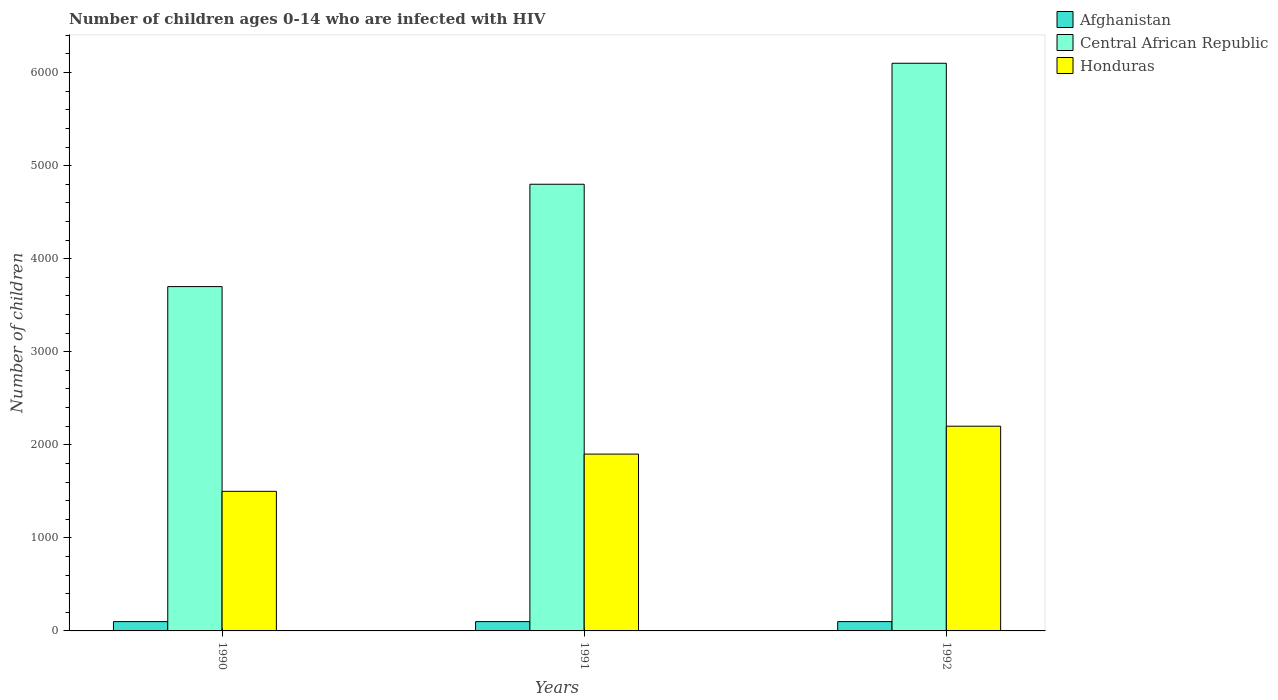How many groups of bars are there?
Offer a very short reply. 3. Are the number of bars per tick equal to the number of legend labels?
Provide a succinct answer. Yes. How many bars are there on the 3rd tick from the right?
Provide a short and direct response. 3. What is the label of the 1st group of bars from the left?
Your response must be concise. 1990. In how many cases, is the number of bars for a given year not equal to the number of legend labels?
Offer a very short reply. 0. What is the number of HIV infected children in Afghanistan in 1990?
Your response must be concise. 100. Across all years, what is the maximum number of HIV infected children in Central African Republic?
Provide a short and direct response. 6100. Across all years, what is the minimum number of HIV infected children in Honduras?
Offer a terse response. 1500. What is the total number of HIV infected children in Central African Republic in the graph?
Give a very brief answer. 1.46e+04. What is the difference between the number of HIV infected children in Afghanistan in 1992 and the number of HIV infected children in Honduras in 1990?
Give a very brief answer. -1400. What is the average number of HIV infected children in Central African Republic per year?
Provide a short and direct response. 4866.67. In the year 1990, what is the difference between the number of HIV infected children in Honduras and number of HIV infected children in Central African Republic?
Ensure brevity in your answer.  -2200. What is the ratio of the number of HIV infected children in Honduras in 1991 to that in 1992?
Your answer should be very brief. 0.86. Is the number of HIV infected children in Honduras in 1990 less than that in 1992?
Provide a succinct answer. Yes. What is the difference between the highest and the second highest number of HIV infected children in Honduras?
Make the answer very short. 300. What is the difference between the highest and the lowest number of HIV infected children in Central African Republic?
Give a very brief answer. 2400. In how many years, is the number of HIV infected children in Honduras greater than the average number of HIV infected children in Honduras taken over all years?
Provide a succinct answer. 2. Is the sum of the number of HIV infected children in Central African Republic in 1990 and 1992 greater than the maximum number of HIV infected children in Afghanistan across all years?
Keep it short and to the point. Yes. What does the 2nd bar from the left in 1992 represents?
Your answer should be compact. Central African Republic. What does the 2nd bar from the right in 1991 represents?
Ensure brevity in your answer.  Central African Republic. Is it the case that in every year, the sum of the number of HIV infected children in Central African Republic and number of HIV infected children in Afghanistan is greater than the number of HIV infected children in Honduras?
Offer a very short reply. Yes. How many bars are there?
Ensure brevity in your answer.  9. What is the difference between two consecutive major ticks on the Y-axis?
Provide a succinct answer. 1000. Does the graph contain any zero values?
Offer a very short reply. No. Does the graph contain grids?
Offer a very short reply. No. How are the legend labels stacked?
Offer a very short reply. Vertical. What is the title of the graph?
Provide a short and direct response. Number of children ages 0-14 who are infected with HIV. What is the label or title of the Y-axis?
Your response must be concise. Number of children. What is the Number of children of Afghanistan in 1990?
Your answer should be very brief. 100. What is the Number of children of Central African Republic in 1990?
Your response must be concise. 3700. What is the Number of children in Honduras in 1990?
Provide a succinct answer. 1500. What is the Number of children of Afghanistan in 1991?
Your answer should be compact. 100. What is the Number of children in Central African Republic in 1991?
Give a very brief answer. 4800. What is the Number of children in Honduras in 1991?
Keep it short and to the point. 1900. What is the Number of children of Afghanistan in 1992?
Your answer should be very brief. 100. What is the Number of children in Central African Republic in 1992?
Offer a terse response. 6100. What is the Number of children of Honduras in 1992?
Provide a short and direct response. 2200. Across all years, what is the maximum Number of children of Afghanistan?
Keep it short and to the point. 100. Across all years, what is the maximum Number of children in Central African Republic?
Keep it short and to the point. 6100. Across all years, what is the maximum Number of children in Honduras?
Your answer should be very brief. 2200. Across all years, what is the minimum Number of children of Central African Republic?
Your answer should be compact. 3700. Across all years, what is the minimum Number of children in Honduras?
Provide a short and direct response. 1500. What is the total Number of children of Afghanistan in the graph?
Offer a very short reply. 300. What is the total Number of children in Central African Republic in the graph?
Provide a succinct answer. 1.46e+04. What is the total Number of children in Honduras in the graph?
Offer a terse response. 5600. What is the difference between the Number of children of Central African Republic in 1990 and that in 1991?
Offer a very short reply. -1100. What is the difference between the Number of children in Honduras in 1990 and that in 1991?
Keep it short and to the point. -400. What is the difference between the Number of children of Central African Republic in 1990 and that in 1992?
Provide a short and direct response. -2400. What is the difference between the Number of children of Honduras in 1990 and that in 1992?
Your answer should be very brief. -700. What is the difference between the Number of children of Afghanistan in 1991 and that in 1992?
Give a very brief answer. 0. What is the difference between the Number of children in Central African Republic in 1991 and that in 1992?
Keep it short and to the point. -1300. What is the difference between the Number of children of Honduras in 1991 and that in 1992?
Keep it short and to the point. -300. What is the difference between the Number of children in Afghanistan in 1990 and the Number of children in Central African Republic in 1991?
Your answer should be compact. -4700. What is the difference between the Number of children of Afghanistan in 1990 and the Number of children of Honduras in 1991?
Offer a very short reply. -1800. What is the difference between the Number of children of Central African Republic in 1990 and the Number of children of Honduras in 1991?
Your answer should be very brief. 1800. What is the difference between the Number of children of Afghanistan in 1990 and the Number of children of Central African Republic in 1992?
Keep it short and to the point. -6000. What is the difference between the Number of children in Afghanistan in 1990 and the Number of children in Honduras in 1992?
Give a very brief answer. -2100. What is the difference between the Number of children of Central African Republic in 1990 and the Number of children of Honduras in 1992?
Offer a terse response. 1500. What is the difference between the Number of children of Afghanistan in 1991 and the Number of children of Central African Republic in 1992?
Your answer should be compact. -6000. What is the difference between the Number of children of Afghanistan in 1991 and the Number of children of Honduras in 1992?
Keep it short and to the point. -2100. What is the difference between the Number of children in Central African Republic in 1991 and the Number of children in Honduras in 1992?
Provide a succinct answer. 2600. What is the average Number of children in Afghanistan per year?
Offer a terse response. 100. What is the average Number of children in Central African Republic per year?
Provide a short and direct response. 4866.67. What is the average Number of children in Honduras per year?
Your answer should be compact. 1866.67. In the year 1990, what is the difference between the Number of children of Afghanistan and Number of children of Central African Republic?
Give a very brief answer. -3600. In the year 1990, what is the difference between the Number of children of Afghanistan and Number of children of Honduras?
Your answer should be very brief. -1400. In the year 1990, what is the difference between the Number of children of Central African Republic and Number of children of Honduras?
Make the answer very short. 2200. In the year 1991, what is the difference between the Number of children of Afghanistan and Number of children of Central African Republic?
Provide a succinct answer. -4700. In the year 1991, what is the difference between the Number of children in Afghanistan and Number of children in Honduras?
Ensure brevity in your answer.  -1800. In the year 1991, what is the difference between the Number of children in Central African Republic and Number of children in Honduras?
Give a very brief answer. 2900. In the year 1992, what is the difference between the Number of children in Afghanistan and Number of children in Central African Republic?
Your response must be concise. -6000. In the year 1992, what is the difference between the Number of children in Afghanistan and Number of children in Honduras?
Your response must be concise. -2100. In the year 1992, what is the difference between the Number of children in Central African Republic and Number of children in Honduras?
Your answer should be very brief. 3900. What is the ratio of the Number of children in Central African Republic in 1990 to that in 1991?
Make the answer very short. 0.77. What is the ratio of the Number of children of Honduras in 1990 to that in 1991?
Give a very brief answer. 0.79. What is the ratio of the Number of children of Afghanistan in 1990 to that in 1992?
Make the answer very short. 1. What is the ratio of the Number of children in Central African Republic in 1990 to that in 1992?
Provide a short and direct response. 0.61. What is the ratio of the Number of children of Honduras in 1990 to that in 1992?
Provide a short and direct response. 0.68. What is the ratio of the Number of children of Afghanistan in 1991 to that in 1992?
Your response must be concise. 1. What is the ratio of the Number of children of Central African Republic in 1991 to that in 1992?
Keep it short and to the point. 0.79. What is the ratio of the Number of children of Honduras in 1991 to that in 1992?
Offer a very short reply. 0.86. What is the difference between the highest and the second highest Number of children of Central African Republic?
Offer a terse response. 1300. What is the difference between the highest and the second highest Number of children of Honduras?
Your answer should be very brief. 300. What is the difference between the highest and the lowest Number of children in Central African Republic?
Keep it short and to the point. 2400. What is the difference between the highest and the lowest Number of children in Honduras?
Your answer should be very brief. 700. 